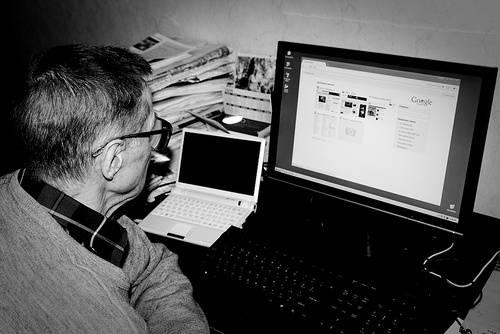Describe the objects in this image and their specific colors. I can see laptop in black, lightgray, gray, and darkgray tones, people in black, gray, darkgray, and lightgray tones, tv in black, lightgray, gray, and darkgray tones, keyboard in black, gray, gainsboro, and darkgray tones, and laptop in black, lightgray, darkgray, and gray tones in this image. 